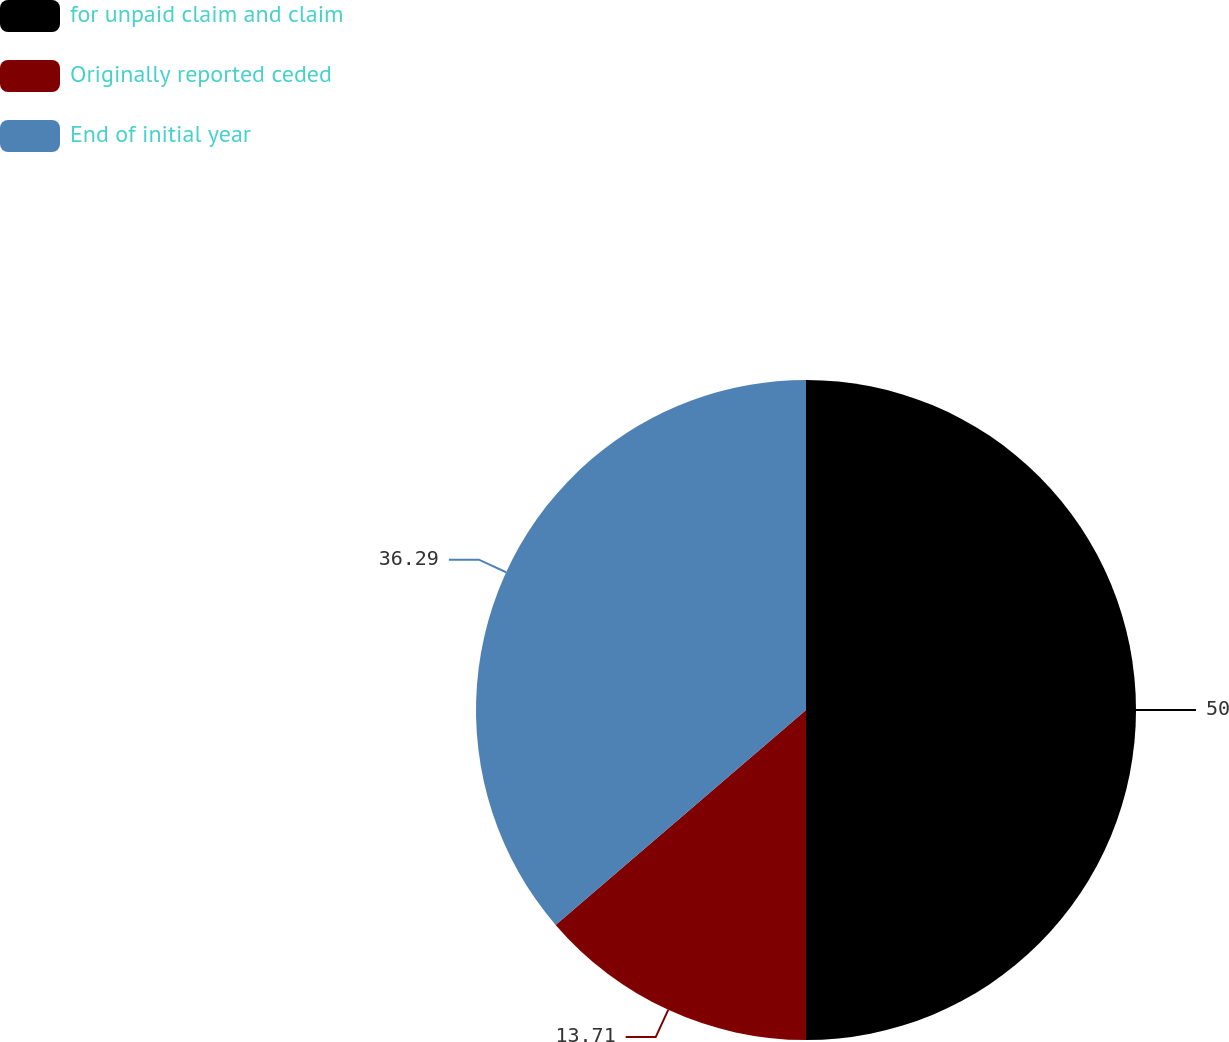<chart> <loc_0><loc_0><loc_500><loc_500><pie_chart><fcel>for unpaid claim and claim<fcel>Originally reported ceded<fcel>End of initial year<nl><fcel>50.0%<fcel>13.71%<fcel>36.29%<nl></chart> 